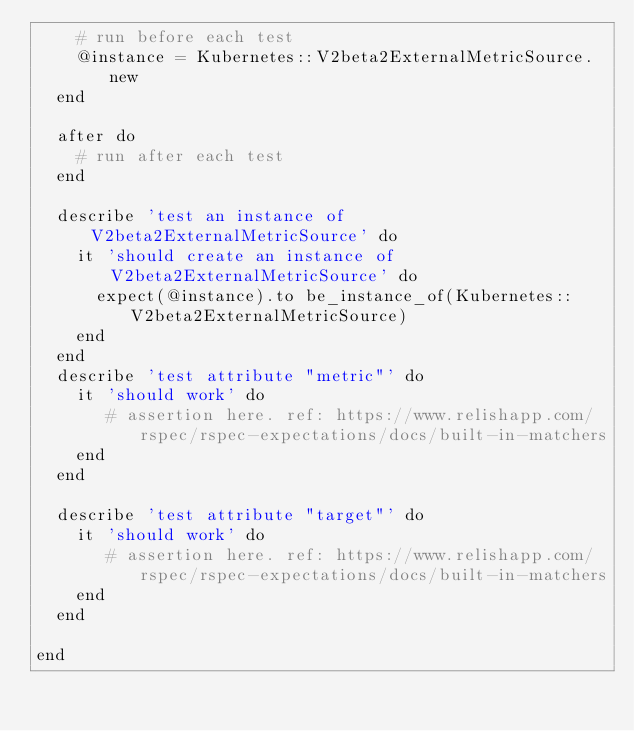<code> <loc_0><loc_0><loc_500><loc_500><_Ruby_>    # run before each test
    @instance = Kubernetes::V2beta2ExternalMetricSource.new
  end

  after do
    # run after each test
  end

  describe 'test an instance of V2beta2ExternalMetricSource' do
    it 'should create an instance of V2beta2ExternalMetricSource' do
      expect(@instance).to be_instance_of(Kubernetes::V2beta2ExternalMetricSource)
    end
  end
  describe 'test attribute "metric"' do
    it 'should work' do
       # assertion here. ref: https://www.relishapp.com/rspec/rspec-expectations/docs/built-in-matchers
    end
  end

  describe 'test attribute "target"' do
    it 'should work' do
       # assertion here. ref: https://www.relishapp.com/rspec/rspec-expectations/docs/built-in-matchers
    end
  end

end

</code> 